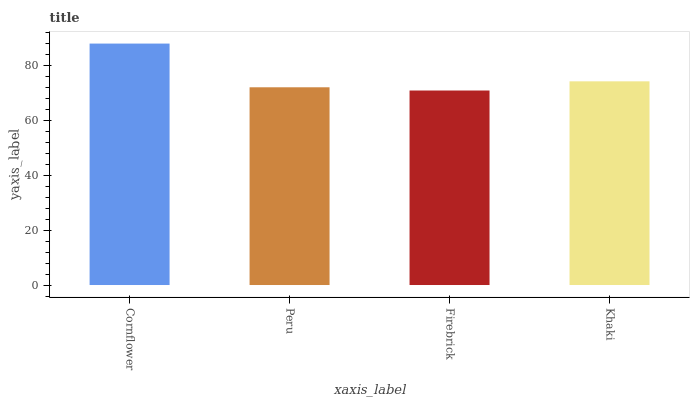Is Firebrick the minimum?
Answer yes or no. Yes. Is Cornflower the maximum?
Answer yes or no. Yes. Is Peru the minimum?
Answer yes or no. No. Is Peru the maximum?
Answer yes or no. No. Is Cornflower greater than Peru?
Answer yes or no. Yes. Is Peru less than Cornflower?
Answer yes or no. Yes. Is Peru greater than Cornflower?
Answer yes or no. No. Is Cornflower less than Peru?
Answer yes or no. No. Is Khaki the high median?
Answer yes or no. Yes. Is Peru the low median?
Answer yes or no. Yes. Is Firebrick the high median?
Answer yes or no. No. Is Firebrick the low median?
Answer yes or no. No. 